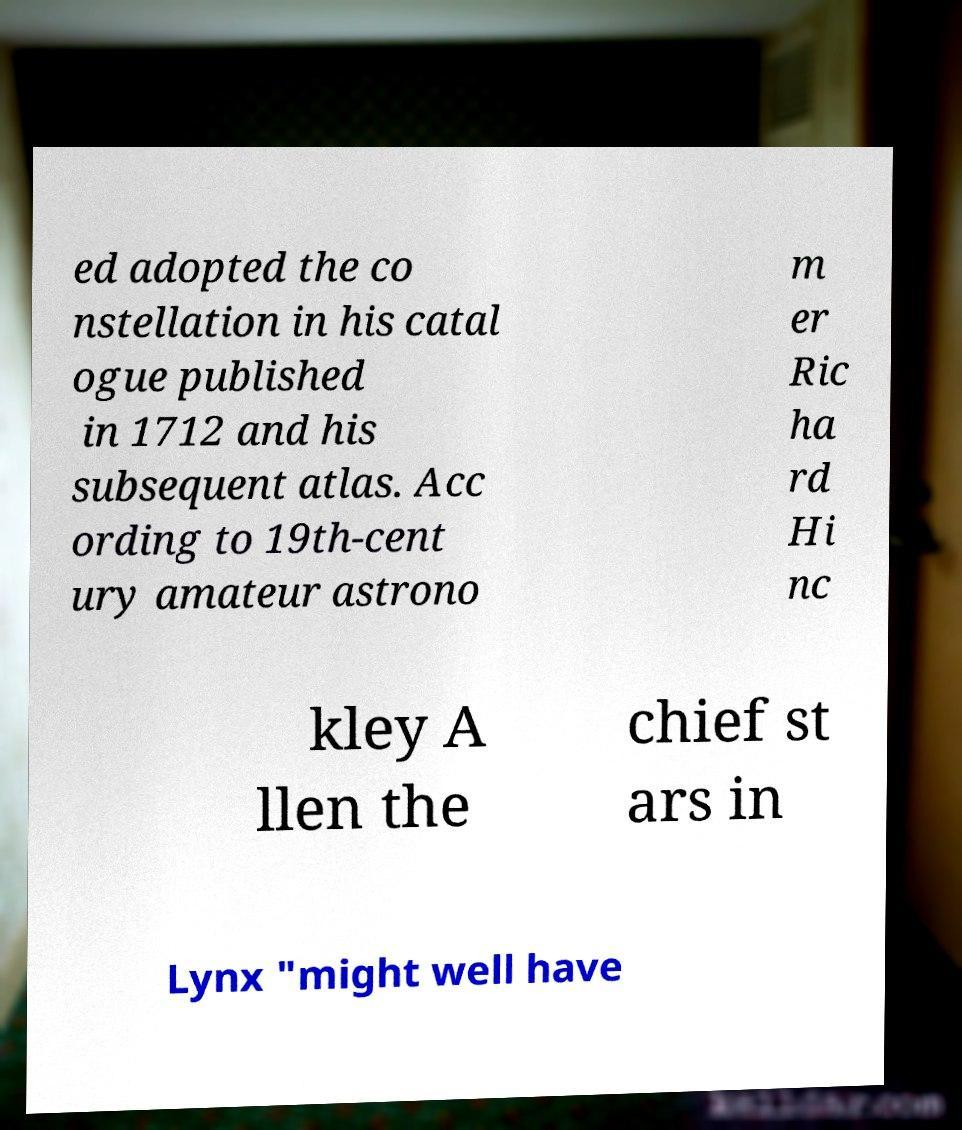Could you extract and type out the text from this image? ed adopted the co nstellation in his catal ogue published in 1712 and his subsequent atlas. Acc ording to 19th-cent ury amateur astrono m er Ric ha rd Hi nc kley A llen the chief st ars in Lynx "might well have 